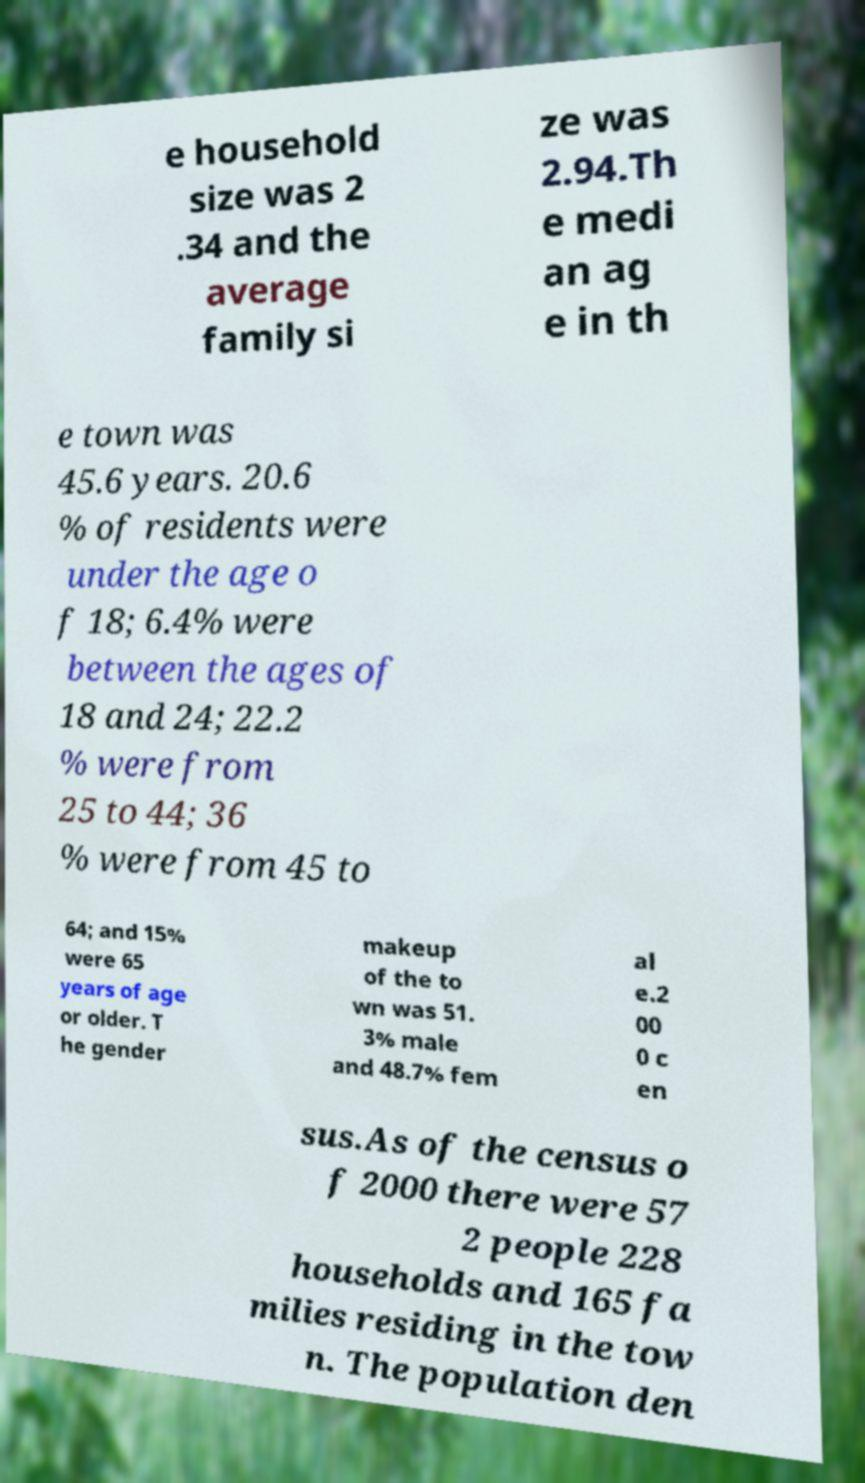There's text embedded in this image that I need extracted. Can you transcribe it verbatim? e household size was 2 .34 and the average family si ze was 2.94.Th e medi an ag e in th e town was 45.6 years. 20.6 % of residents were under the age o f 18; 6.4% were between the ages of 18 and 24; 22.2 % were from 25 to 44; 36 % were from 45 to 64; and 15% were 65 years of age or older. T he gender makeup of the to wn was 51. 3% male and 48.7% fem al e.2 00 0 c en sus.As of the census o f 2000 there were 57 2 people 228 households and 165 fa milies residing in the tow n. The population den 